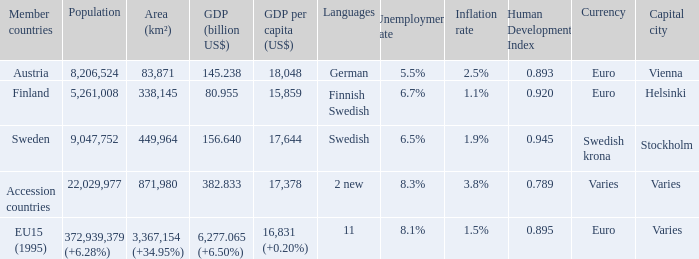Name the area for german 83871.0. 